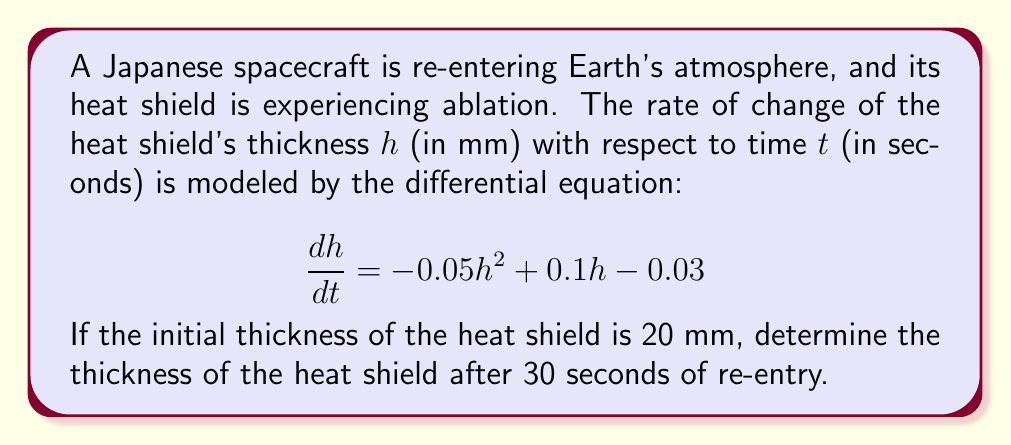Teach me how to tackle this problem. To solve this problem, we need to use the method of separation of variables for first-order differential equations.

1) First, let's rearrange the equation:
   $$\frac{dh}{dt} = -0.05h^2 + 0.1h - 0.03$$
   $$dt = \frac{dh}{-0.05h^2 + 0.1h - 0.03}$$

2) Integrate both sides:
   $$\int dt = \int \frac{dh}{-0.05h^2 + 0.1h - 0.03}$$

3) The right-hand side can be integrated using partial fractions. Let's factor the denominator:
   $$-0.05h^2 + 0.1h - 0.03 = -0.05(h^2 - 2h + 0.6) = -0.05(h - 0.6)(h - 1.4)$$

4) Now, we can write:
   $$t + C = -\frac{1}{0.4} \ln|h - 0.6| + \frac{1}{0.4} \ln|h - 1.4|$$

5) Using the initial condition $h(0) = 20$, we can find $C$:
   $$0 + C = -\frac{1}{0.4} \ln|20 - 0.6| + \frac{1}{0.4} \ln|20 - 1.4|$$
   $$C = -\frac{1}{0.4} \ln(19.4) + \frac{1}{0.4} \ln(18.6) \approx 0.1054$$

6) Substituting this back into our solution:
   $$t + 0.1054 = -\frac{1}{0.4} \ln|h - 0.6| + \frac{1}{0.4} \ln|h - 1.4|$$

7) To find $h$ at $t = 30$, substitute $t = 30$:
   $$30.1054 = -\frac{1}{0.4} \ln|h - 0.6| + \frac{1}{0.4} \ln|h - 1.4|$$

8) This equation can be solved numerically to find $h$.
Answer: The thickness of the heat shield after 30 seconds of re-entry is approximately 1.41 mm. 